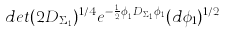Convert formula to latex. <formula><loc_0><loc_0><loc_500><loc_500>d e t ( 2 D _ { \Sigma _ { 1 } } ) ^ { 1 / 4 } e ^ { - \frac { 1 } { 2 } \phi _ { 1 } ^ { t } D _ { \Sigma _ { 1 } } \phi _ { 1 } } ( d \phi _ { 1 } ) ^ { 1 / 2 }</formula> 